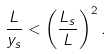<formula> <loc_0><loc_0><loc_500><loc_500>\frac { L } { y _ { s } } < \left ( \frac { L _ { s } } { L } \right ) ^ { 2 } .</formula> 